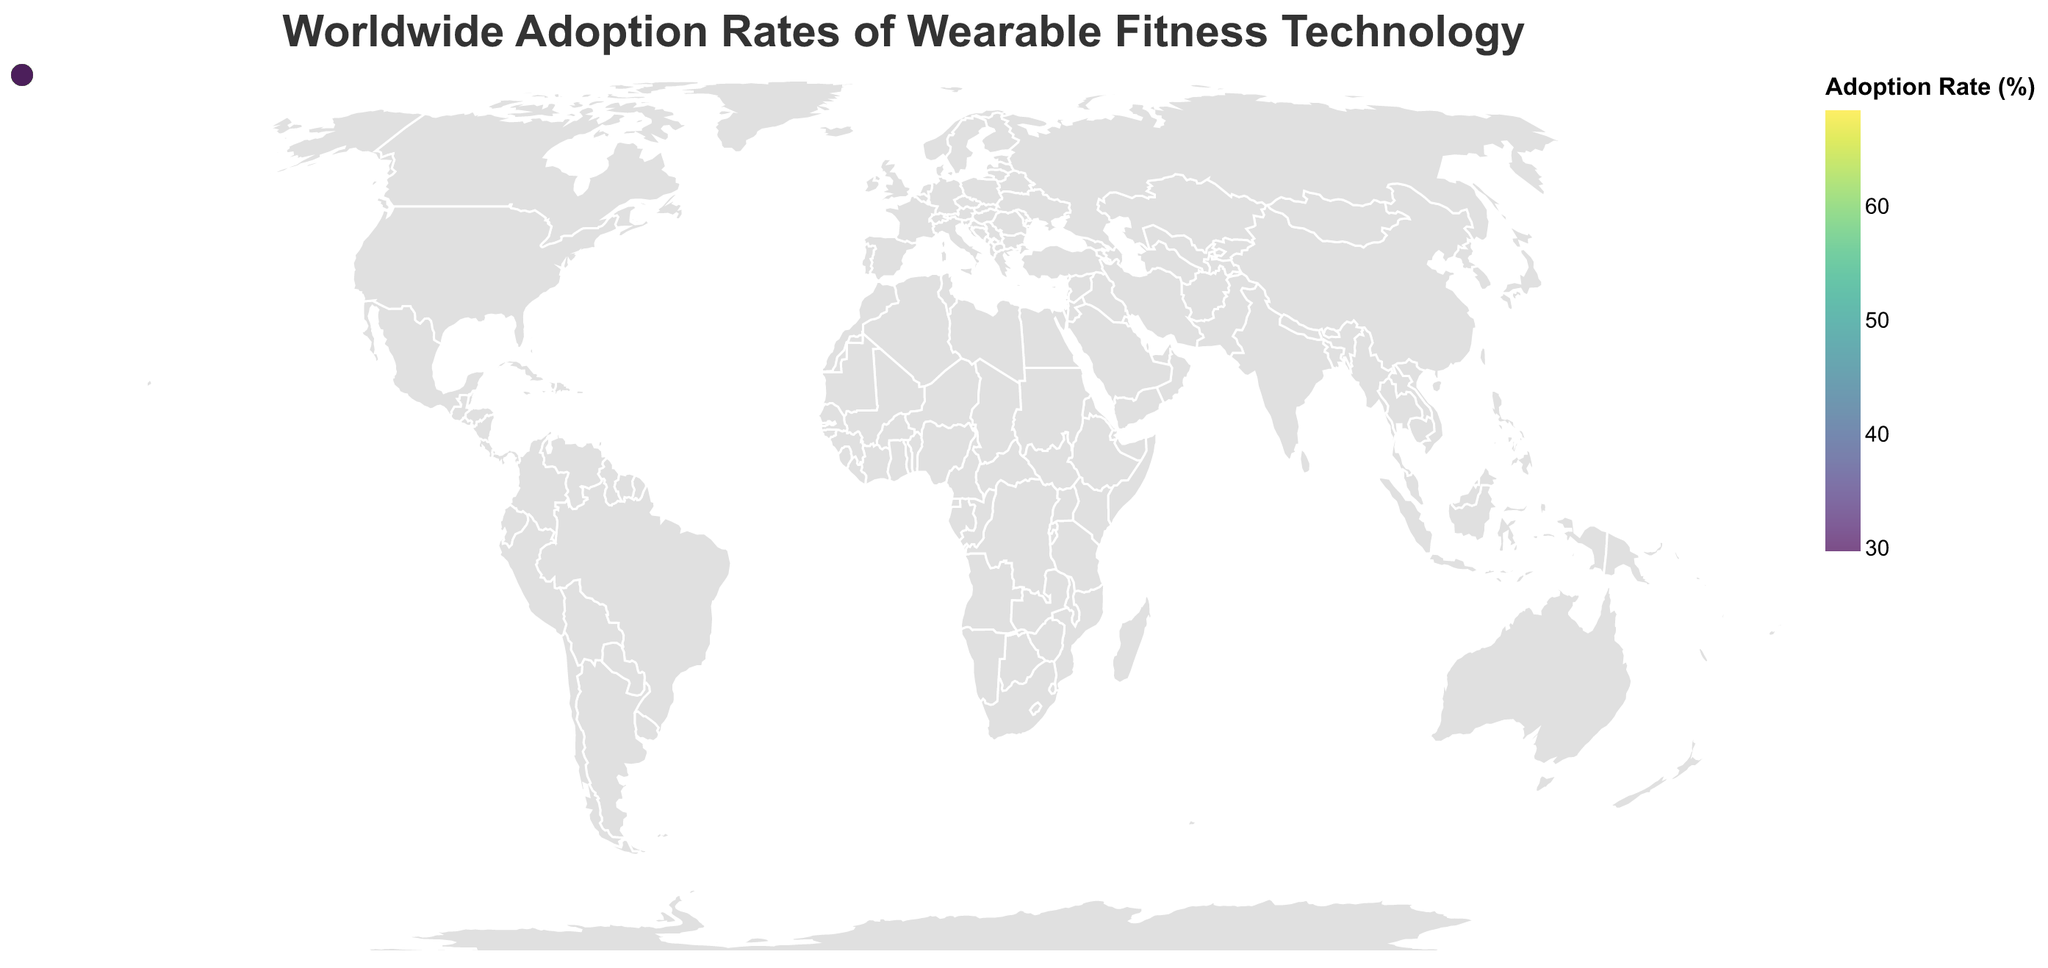What is the title of the figure? The title is always located at the top of the figure and typically provides a brief description of what the figure shows. In this case, the title can be found at the top center.
Answer: Worldwide Adoption Rates of Wearable Fitness Technology Which country has the highest adoption rate of wearable fitness technology? By looking at the color-coded circles, the country with the brightest color (indicating the highest value in the legend) should be identified as having the highest adoption rate.
Answer: United States What is the adoption rate of wearable fitness technology in India? To find the adoption rate for a specific country, locate India on the map and refer to its color-coded circle, or check the tooltip by hovering over the area representing India.
Answer: 31.4% Which two countries have adoption rates closest to 60%? Identify the countries with colors that are closest to the color band representing around 60% in the legend, and then verify the exact values through tooltips or by their positions on the map.
Answer: Canada and Singapore What is the difference in adoption rates between the United States and India? Locate the adoption rates for both United States (68.5%) and India (31.4%), then subtract the smaller rate from the larger one: 68.5 - 31.4.
Answer: 37.1% Which continent shows the widest range of adoption rates? To determine this, look at each continent and identify the country with the highest and lowest adoption rates within that continent, then calculate the range (highest rate - lowest rate).
Answer: Asia How does the adoption rate in Brazil compare to that in Mexico? Locate both Brazil and Mexico on the map and compare their color-coded circles or use the tooltips to check their exact adoption rates. Brazil: 38.9%, Mexico: 35.7%.
Answer: Brazil is higher What's the average adoption rate of wearable fitness technology in European countries listed? List the adoption rates of the European countries (UK, Germany, France, Spain, Italy, Netherlands, Sweden, and Switzerland), sum them, and divide by the number of countries: 
(62.7 + 58.9 + 55.6 + 54.2 + 51.8 + 59.5 + 66.3 + 63.5)/8.
Answer: 59.1% Name the countries with an adoption rate below 40%. Identify the countries with colors indicating values below 40% as per the legend, or use the tooltips for precise values.
Answer: India, Brazil, Mexico, South Africa What is the median adoption rate of wearable fitness technology across all listed countries? List out all the adoption rates, sort them in ascending order, and find the middle value. For 20 values: 29.8, 31.4, 35.7, 38.9, 42.7, 45.2, 51.8, 53.6, 54.2, 55.6, 57.3, 58.9, 59.5, 60.9, 61.8, 62.7, 63.5, 64.1, 66.3, 68.5. The median is the average of the 10th and 11th values: (55.6 + 57.3)/2.
Answer: 56.5% 